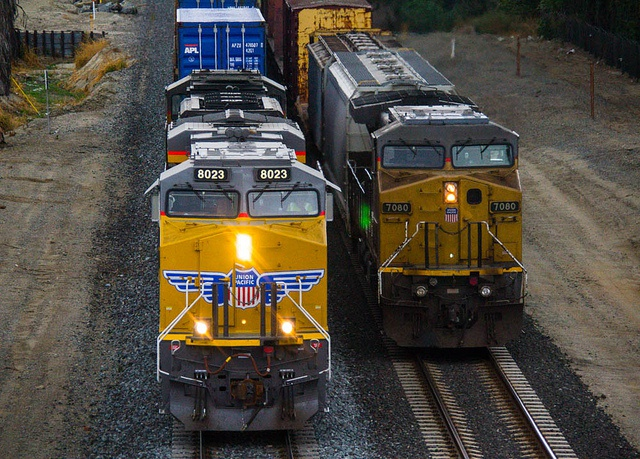Describe the objects in this image and their specific colors. I can see train in black, gray, olive, and orange tones and train in black, gray, olive, and maroon tones in this image. 